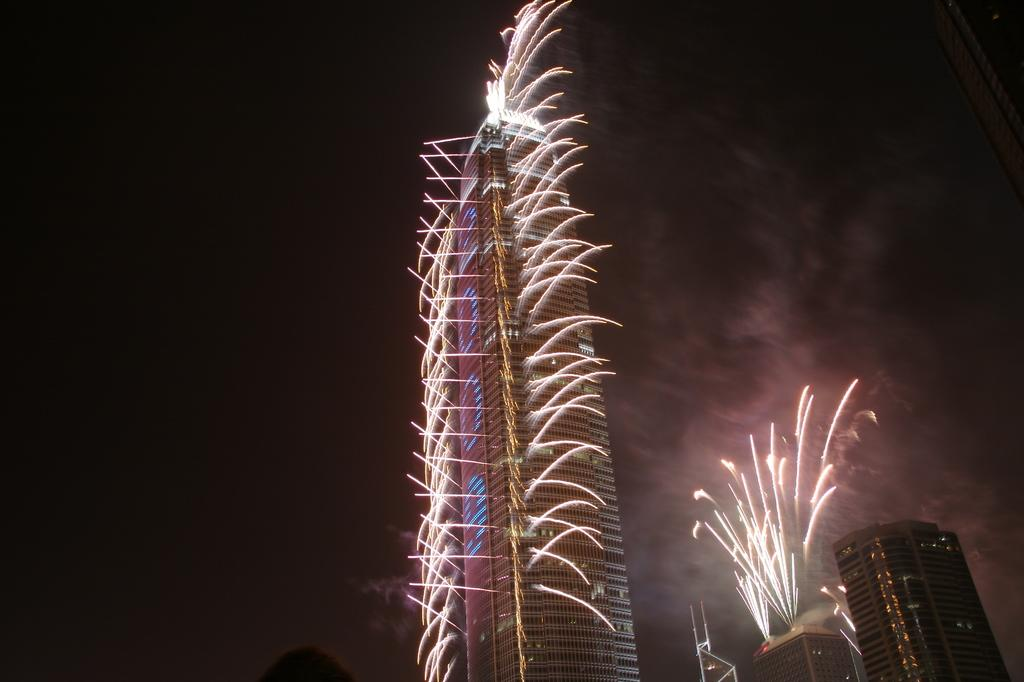What type of structures can be seen in the image? There are buildings in the image. What objects are present that might be associated with a celebration or event? Fire crackers are visible in the image. What type of dress is the building wearing in the image? Buildings do not wear dresses, as they are inanimate structures. 